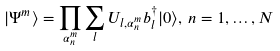Convert formula to latex. <formula><loc_0><loc_0><loc_500><loc_500>| \Psi ^ { m } \rangle = \prod _ { \alpha _ { n } ^ { m } } \sum _ { l } U _ { l , \alpha _ { n } ^ { m } } b _ { l } ^ { \dagger } | 0 \rangle , \, n = 1 , \dots , N</formula> 